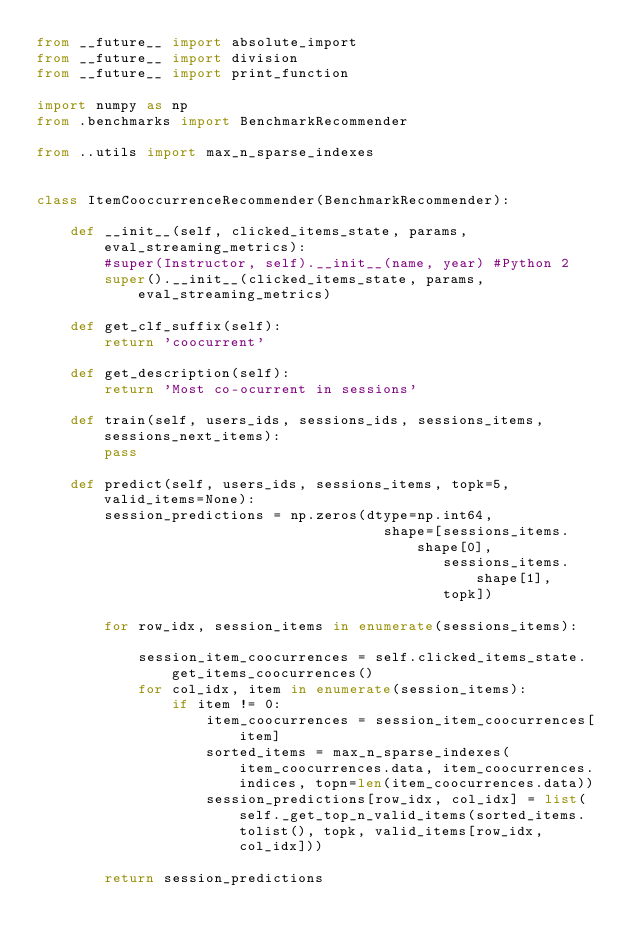<code> <loc_0><loc_0><loc_500><loc_500><_Python_>from __future__ import absolute_import
from __future__ import division
from __future__ import print_function

import numpy as np
from .benchmarks import BenchmarkRecommender

from ..utils import max_n_sparse_indexes


class ItemCooccurrenceRecommender(BenchmarkRecommender):
    
    def __init__(self, clicked_items_state, params, eval_streaming_metrics):
        #super(Instructor, self).__init__(name, year) #Python 2
        super().__init__(clicked_items_state, params, eval_streaming_metrics)
        
    def get_clf_suffix(self):
        return 'coocurrent'
        
    def get_description(self):
        return 'Most co-ocurrent in sessions'
        
    def train(self, users_ids, sessions_ids, sessions_items, sessions_next_items):
        pass
    
    def predict(self, users_ids, sessions_items, topk=5, valid_items=None):
        session_predictions = np.zeros(dtype=np.int64,
                                         shape=[sessions_items.shape[0],
                                                sessions_items.shape[1],
                                                topk])
                     
        for row_idx, session_items in enumerate(sessions_items):            

            session_item_coocurrences = self.clicked_items_state.get_items_coocurrences()
            for col_idx, item in enumerate(session_items):
                if item != 0:
                    item_coocurrences = session_item_coocurrences[item]
                    sorted_items = max_n_sparse_indexes(item_coocurrences.data, item_coocurrences.indices, topn=len(item_coocurrences.data))
                    session_predictions[row_idx, col_idx] = list(self._get_top_n_valid_items(sorted_items.tolist(), topk, valid_items[row_idx, col_idx]))
            
        return session_predictions  </code> 